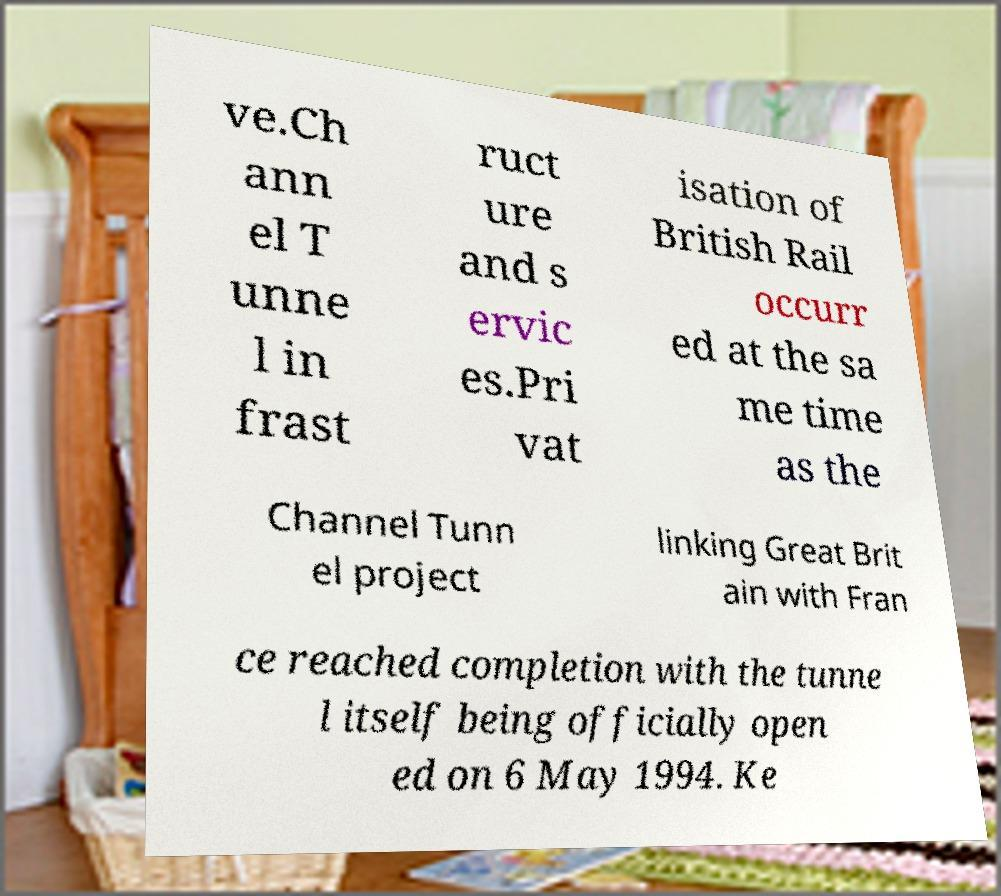There's text embedded in this image that I need extracted. Can you transcribe it verbatim? ve.Ch ann el T unne l in frast ruct ure and s ervic es.Pri vat isation of British Rail occurr ed at the sa me time as the Channel Tunn el project linking Great Brit ain with Fran ce reached completion with the tunne l itself being officially open ed on 6 May 1994. Ke 